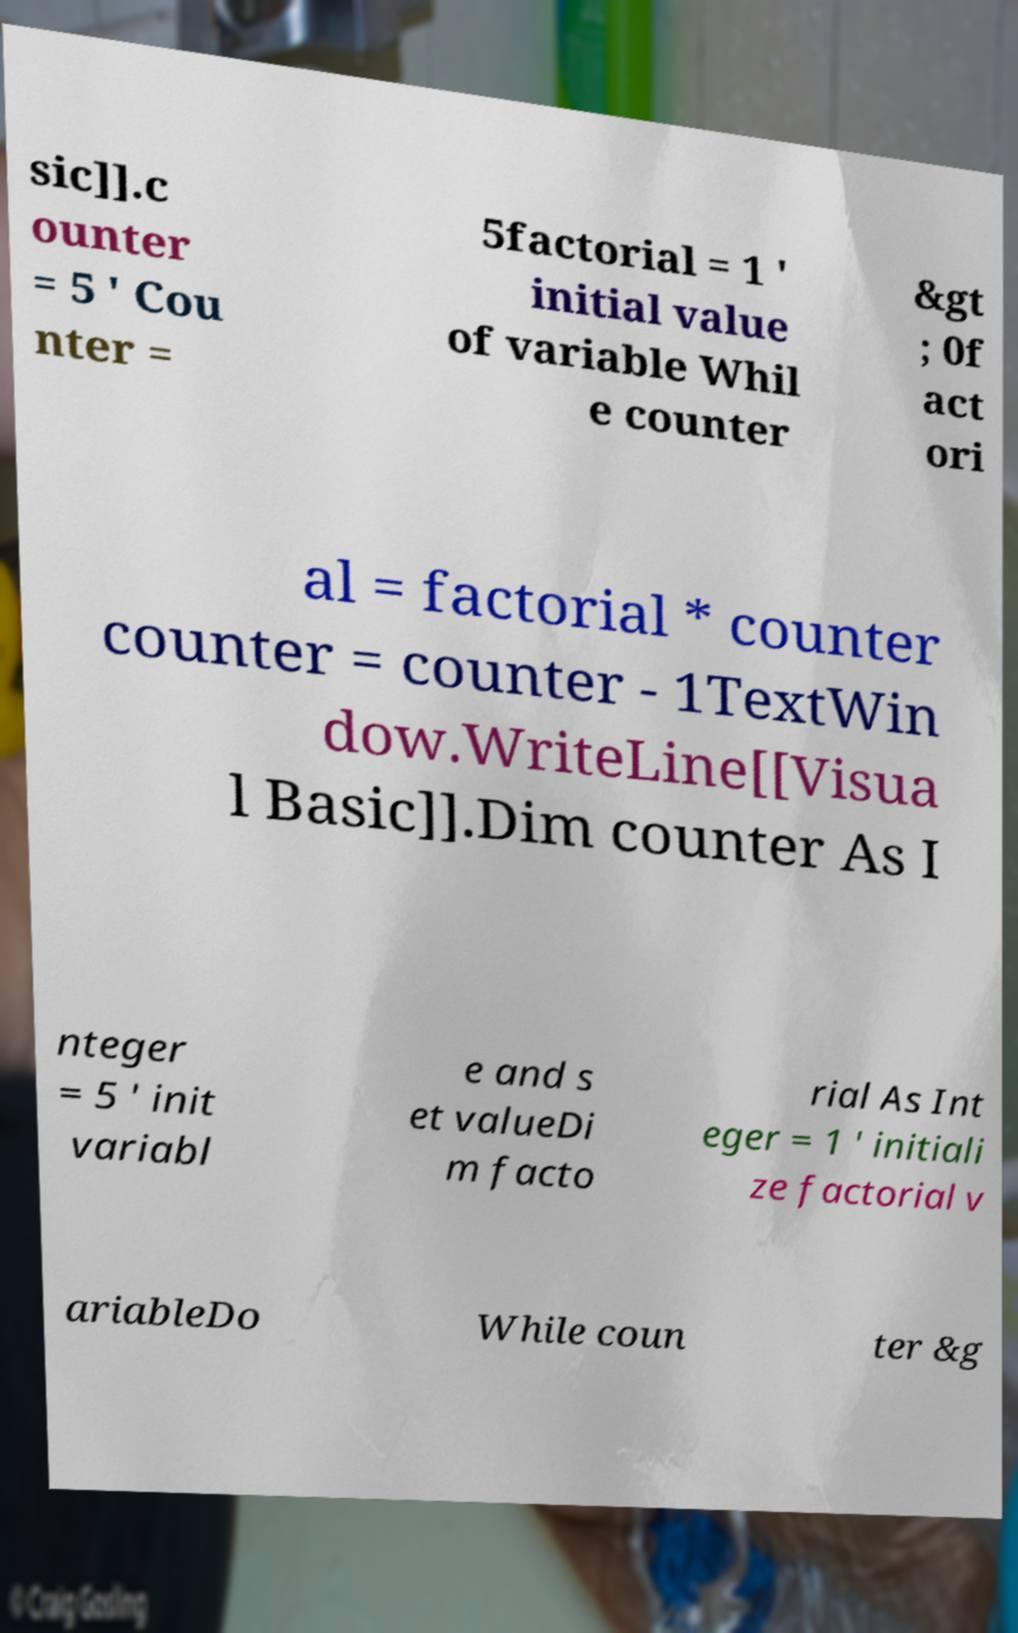I need the written content from this picture converted into text. Can you do that? sic]].c ounter = 5 ' Cou nter = 5factorial = 1 ' initial value of variable Whil e counter &gt ; 0f act ori al = factorial * counter counter = counter - 1TextWin dow.WriteLine[[Visua l Basic]].Dim counter As I nteger = 5 ' init variabl e and s et valueDi m facto rial As Int eger = 1 ' initiali ze factorial v ariableDo While coun ter &g 